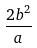Convert formula to latex. <formula><loc_0><loc_0><loc_500><loc_500>\frac { 2 b ^ { 2 } } { a }</formula> 